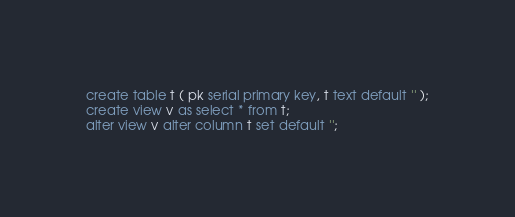Convert code to text. <code><loc_0><loc_0><loc_500><loc_500><_SQL_>create table t ( pk serial primary key, t text default '' );
create view v as select * from t;
alter view v alter column t set default '';
</code> 